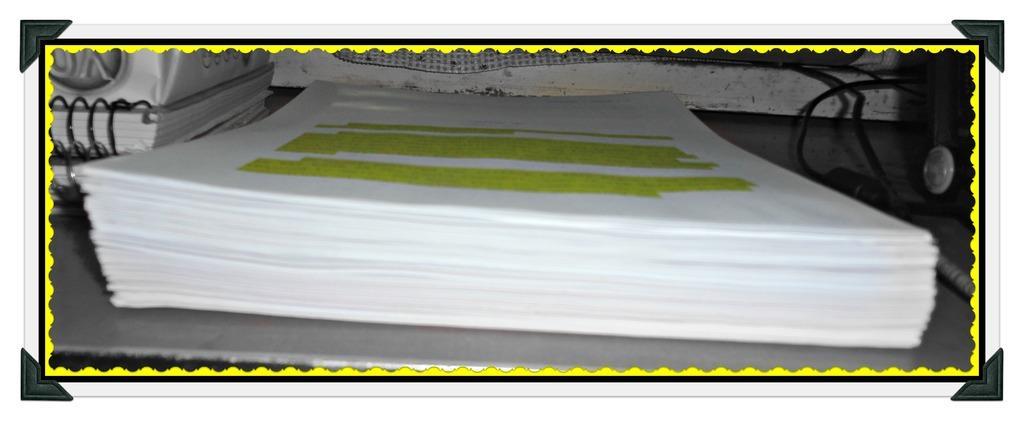Please provide a concise description of this image. This is an edited image. I can see a bundle of papers, books and cables on an object. 